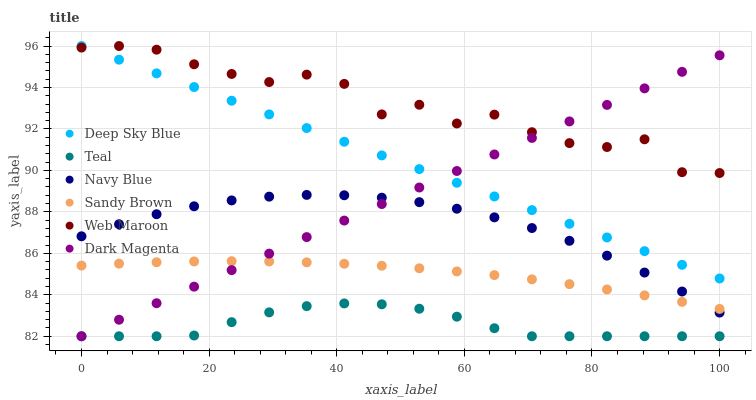Does Teal have the minimum area under the curve?
Answer yes or no. Yes. Does Web Maroon have the maximum area under the curve?
Answer yes or no. Yes. Does Navy Blue have the minimum area under the curve?
Answer yes or no. No. Does Navy Blue have the maximum area under the curve?
Answer yes or no. No. Is Deep Sky Blue the smoothest?
Answer yes or no. Yes. Is Web Maroon the roughest?
Answer yes or no. Yes. Is Navy Blue the smoothest?
Answer yes or no. No. Is Navy Blue the roughest?
Answer yes or no. No. Does Teal have the lowest value?
Answer yes or no. Yes. Does Navy Blue have the lowest value?
Answer yes or no. No. Does Web Maroon have the highest value?
Answer yes or no. Yes. Does Navy Blue have the highest value?
Answer yes or no. No. Is Sandy Brown less than Web Maroon?
Answer yes or no. Yes. Is Web Maroon greater than Navy Blue?
Answer yes or no. Yes. Does Deep Sky Blue intersect Dark Magenta?
Answer yes or no. Yes. Is Deep Sky Blue less than Dark Magenta?
Answer yes or no. No. Is Deep Sky Blue greater than Dark Magenta?
Answer yes or no. No. Does Sandy Brown intersect Web Maroon?
Answer yes or no. No. 